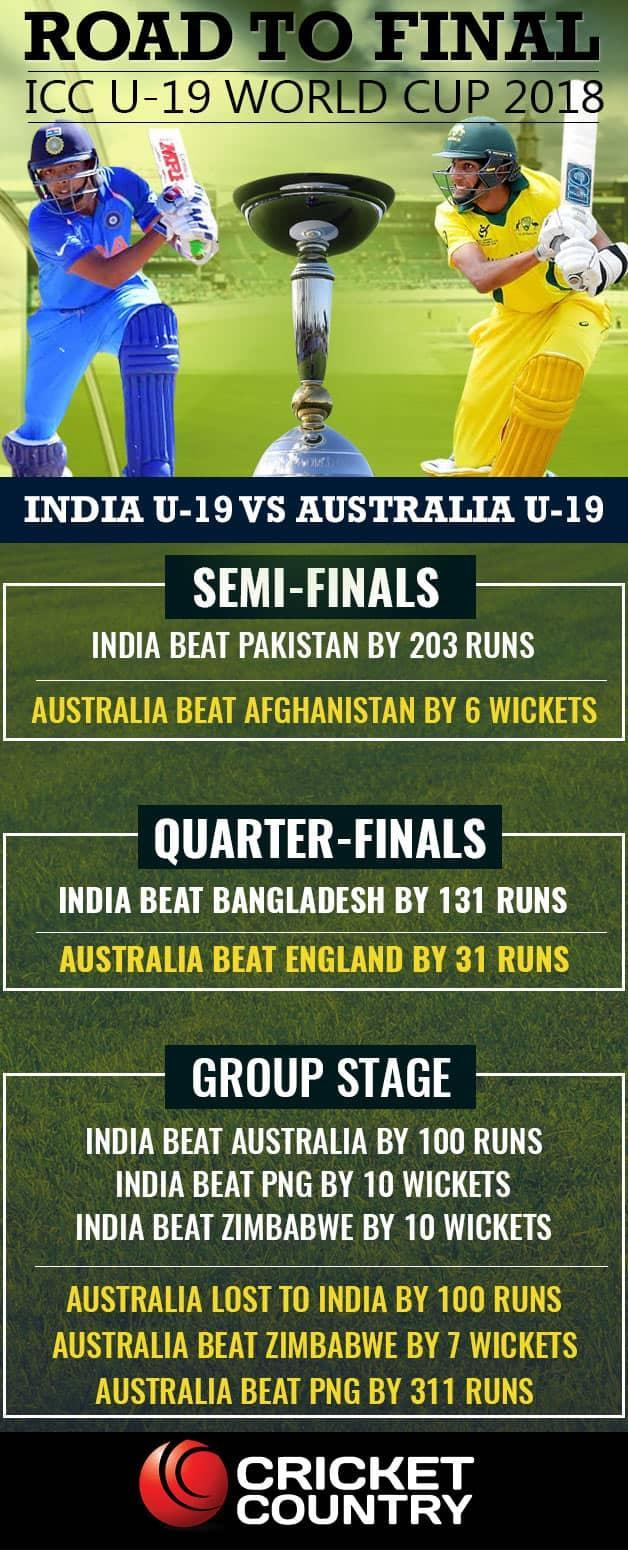Against which all countries India has the big win by wicket?
Answer the question with a short phrase. PNG, zimbabwe How many quarter-finals? 2 Against which country Australia has the big win by run? PNG How many group stage matches? 6 How many wins for Australia? 4 Against which country India has the big win by run? Pakistan How many semi-finals? 2 How many wins for India? 6 Against which country India has the smallest win by run? Australia 